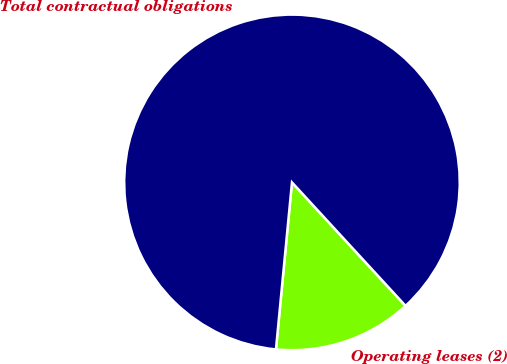<chart> <loc_0><loc_0><loc_500><loc_500><pie_chart><fcel>Operating leases (2)<fcel>Total contractual obligations<nl><fcel>13.36%<fcel>86.64%<nl></chart> 